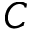<formula> <loc_0><loc_0><loc_500><loc_500>C</formula> 